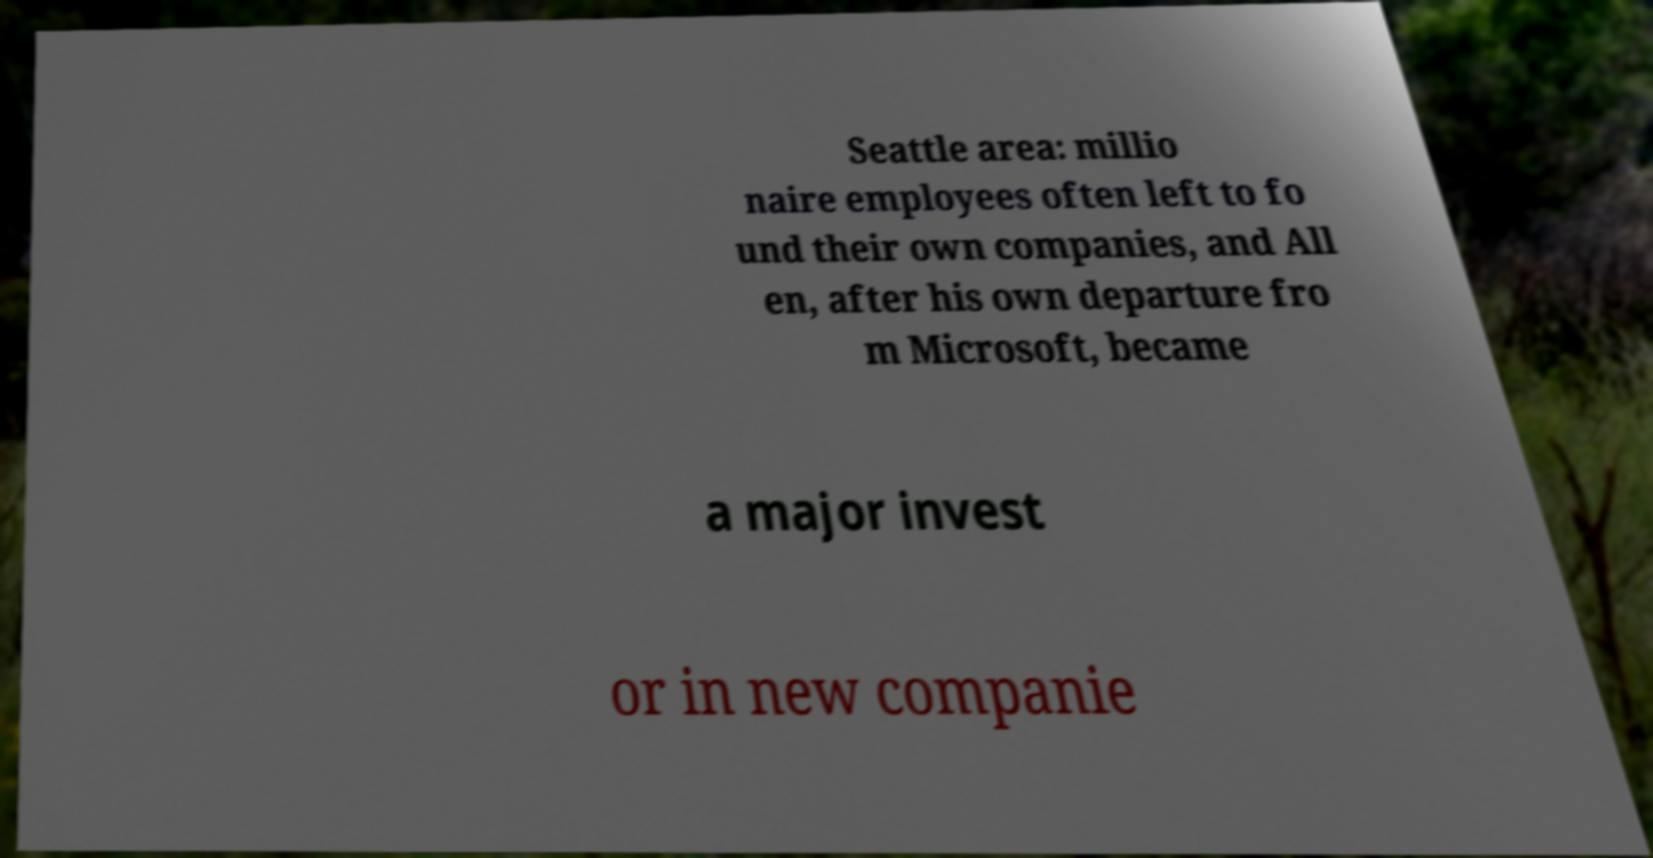Please identify and transcribe the text found in this image. Seattle area: millio naire employees often left to fo und their own companies, and All en, after his own departure fro m Microsoft, became a major invest or in new companie 